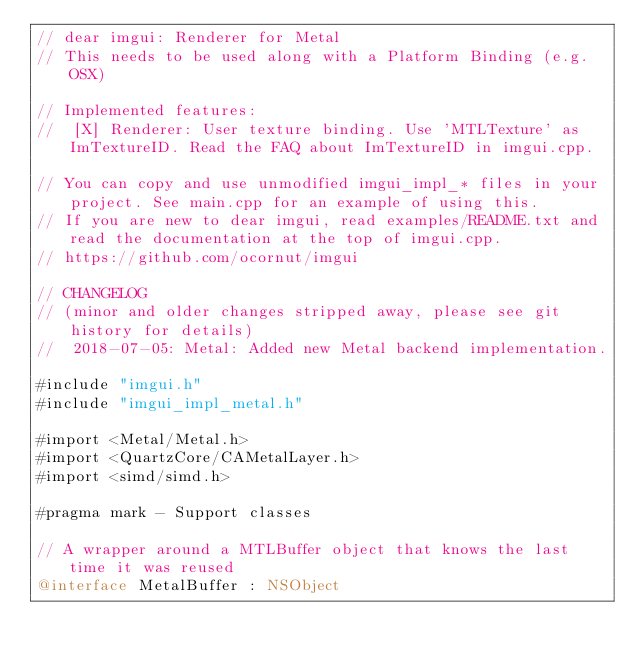<code> <loc_0><loc_0><loc_500><loc_500><_ObjectiveC_>// dear imgui: Renderer for Metal
// This needs to be used along with a Platform Binding (e.g. OSX)

// Implemented features:
//  [X] Renderer: User texture binding. Use 'MTLTexture' as ImTextureID. Read the FAQ about ImTextureID in imgui.cpp.

// You can copy and use unmodified imgui_impl_* files in your project. See main.cpp for an example of using this.
// If you are new to dear imgui, read examples/README.txt and read the documentation at the top of imgui.cpp.
// https://github.com/ocornut/imgui

// CHANGELOG
// (minor and older changes stripped away, please see git history for details)
//  2018-07-05: Metal: Added new Metal backend implementation.

#include "imgui.h"
#include "imgui_impl_metal.h"

#import <Metal/Metal.h>
#import <QuartzCore/CAMetalLayer.h>
#import <simd/simd.h>

#pragma mark - Support classes

// A wrapper around a MTLBuffer object that knows the last time it was reused
@interface MetalBuffer : NSObject</code> 